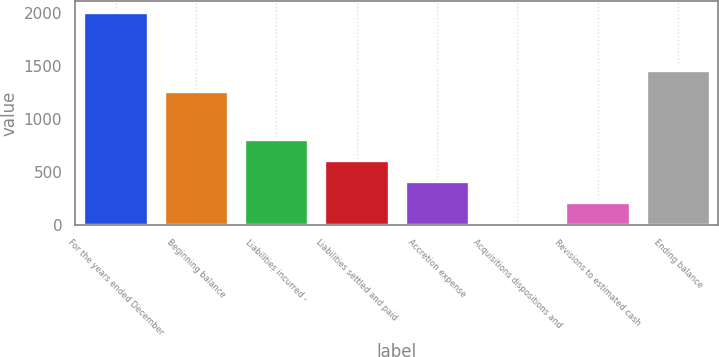Convert chart. <chart><loc_0><loc_0><loc_500><loc_500><bar_chart><fcel>For the years ended December<fcel>Beginning balance<fcel>Liabilities incurred -<fcel>Liabilities settled and paid<fcel>Accretion expense<fcel>Acquisitions dispositions and<fcel>Revisions to estimated cash<fcel>Ending balance<nl><fcel>2013<fcel>1266<fcel>811.2<fcel>610.9<fcel>410.6<fcel>10<fcel>210.3<fcel>1466.3<nl></chart> 